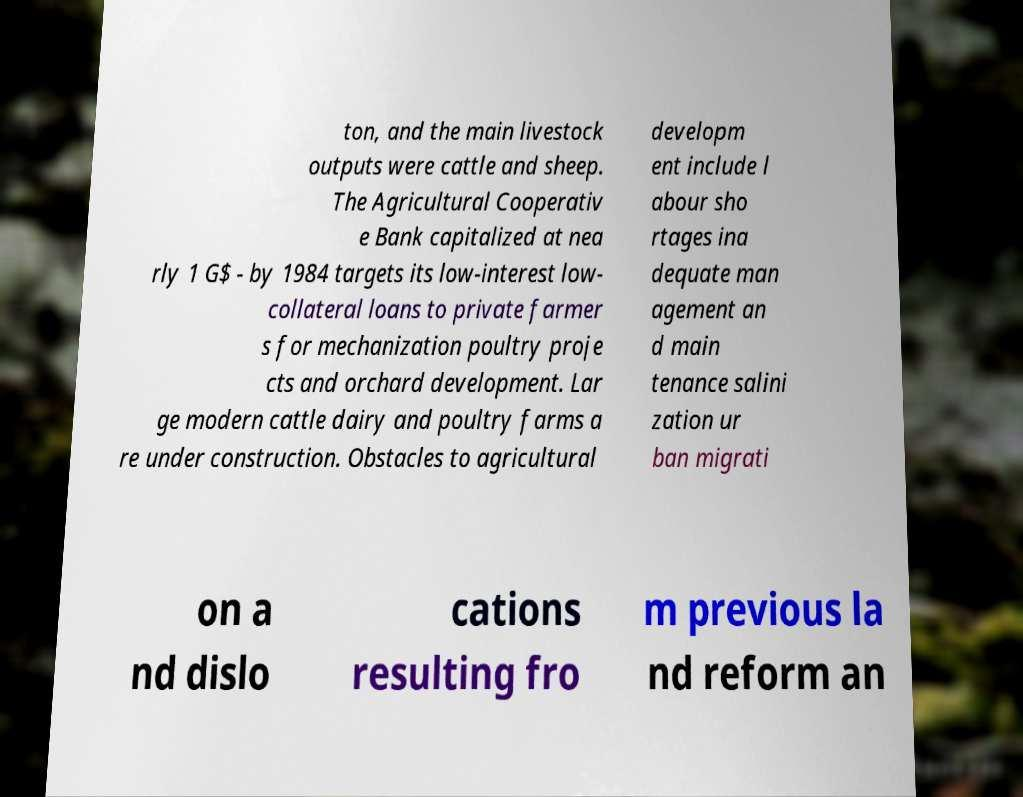Could you assist in decoding the text presented in this image and type it out clearly? ton, and the main livestock outputs were cattle and sheep. The Agricultural Cooperativ e Bank capitalized at nea rly 1 G$ - by 1984 targets its low-interest low- collateral loans to private farmer s for mechanization poultry proje cts and orchard development. Lar ge modern cattle dairy and poultry farms a re under construction. Obstacles to agricultural developm ent include l abour sho rtages ina dequate man agement an d main tenance salini zation ur ban migrati on a nd dislo cations resulting fro m previous la nd reform an 